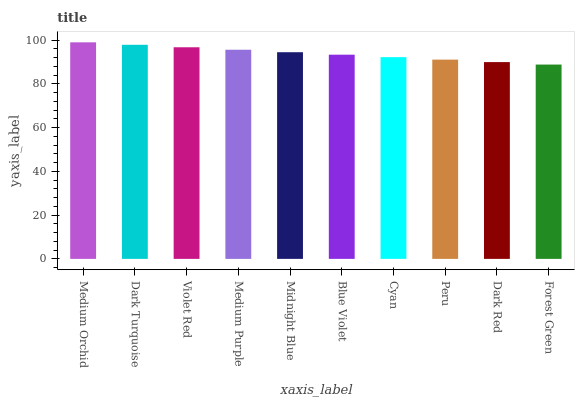Is Forest Green the minimum?
Answer yes or no. Yes. Is Medium Orchid the maximum?
Answer yes or no. Yes. Is Dark Turquoise the minimum?
Answer yes or no. No. Is Dark Turquoise the maximum?
Answer yes or no. No. Is Medium Orchid greater than Dark Turquoise?
Answer yes or no. Yes. Is Dark Turquoise less than Medium Orchid?
Answer yes or no. Yes. Is Dark Turquoise greater than Medium Orchid?
Answer yes or no. No. Is Medium Orchid less than Dark Turquoise?
Answer yes or no. No. Is Midnight Blue the high median?
Answer yes or no. Yes. Is Blue Violet the low median?
Answer yes or no. Yes. Is Forest Green the high median?
Answer yes or no. No. Is Medium Orchid the low median?
Answer yes or no. No. 